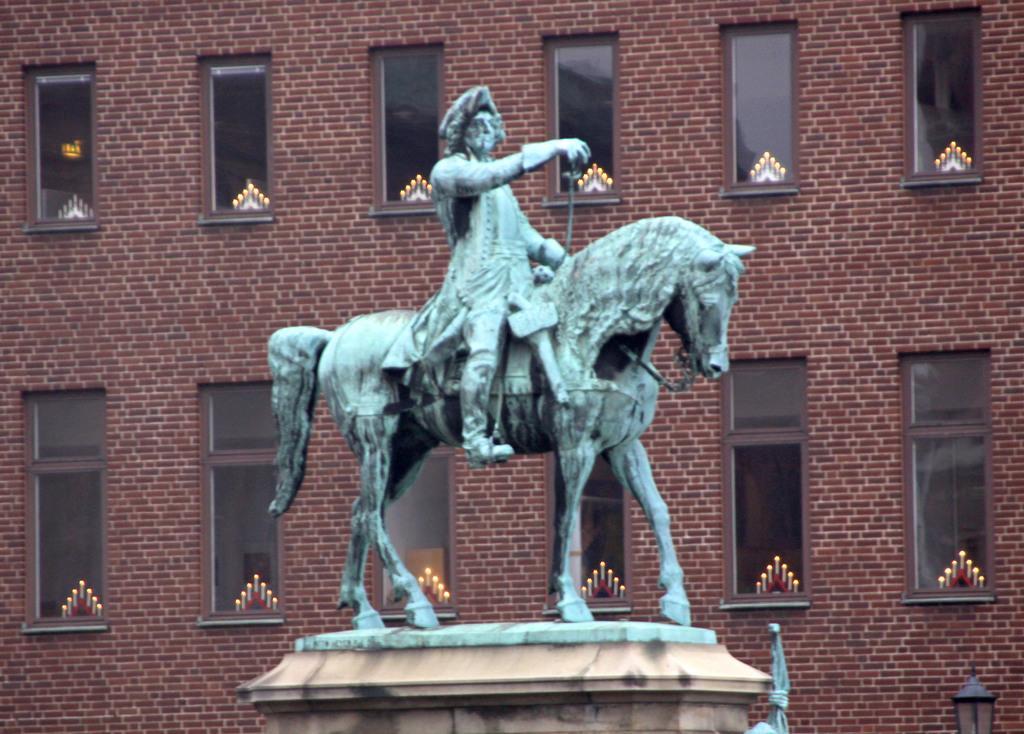Please provide a concise description of this image. In this image there is a statute, in the background there is a building for that building there are windows. 